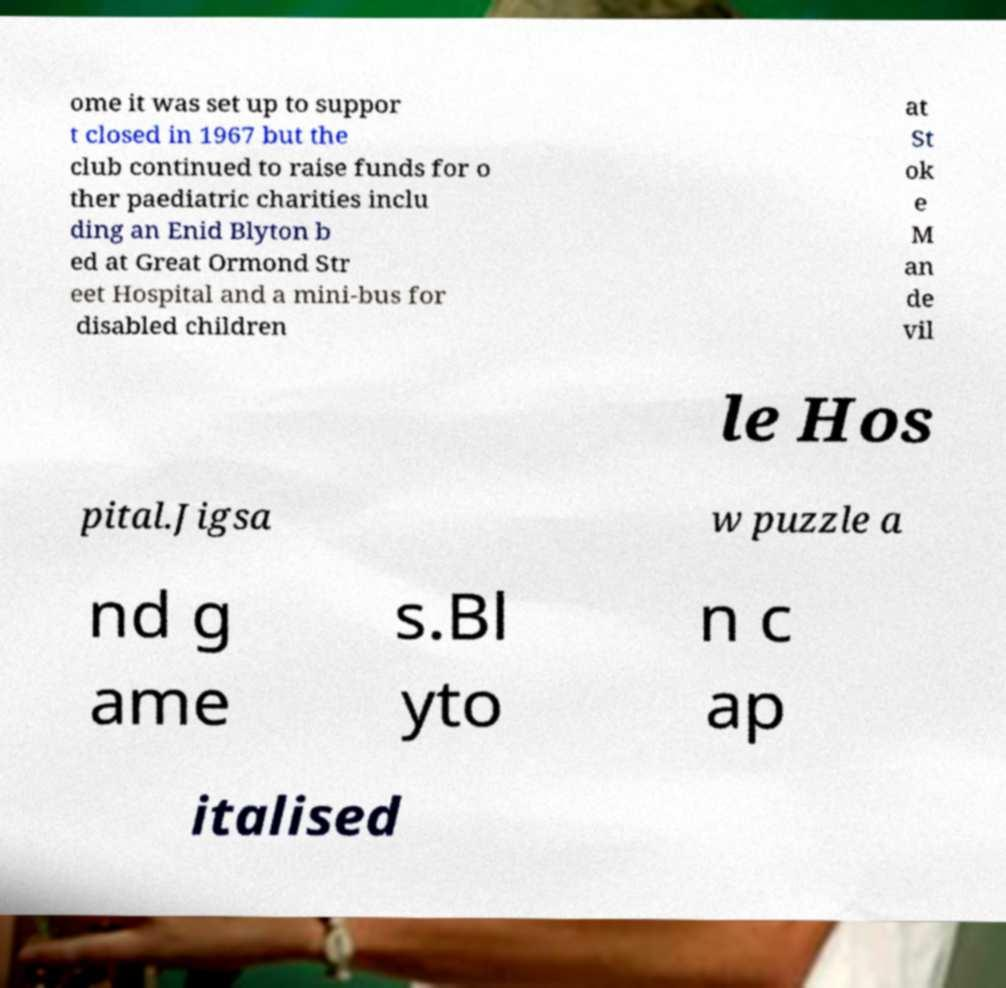Please read and relay the text visible in this image. What does it say? ome it was set up to suppor t closed in 1967 but the club continued to raise funds for o ther paediatric charities inclu ding an Enid Blyton b ed at Great Ormond Str eet Hospital and a mini-bus for disabled children at St ok e M an de vil le Hos pital.Jigsa w puzzle a nd g ame s.Bl yto n c ap italised 